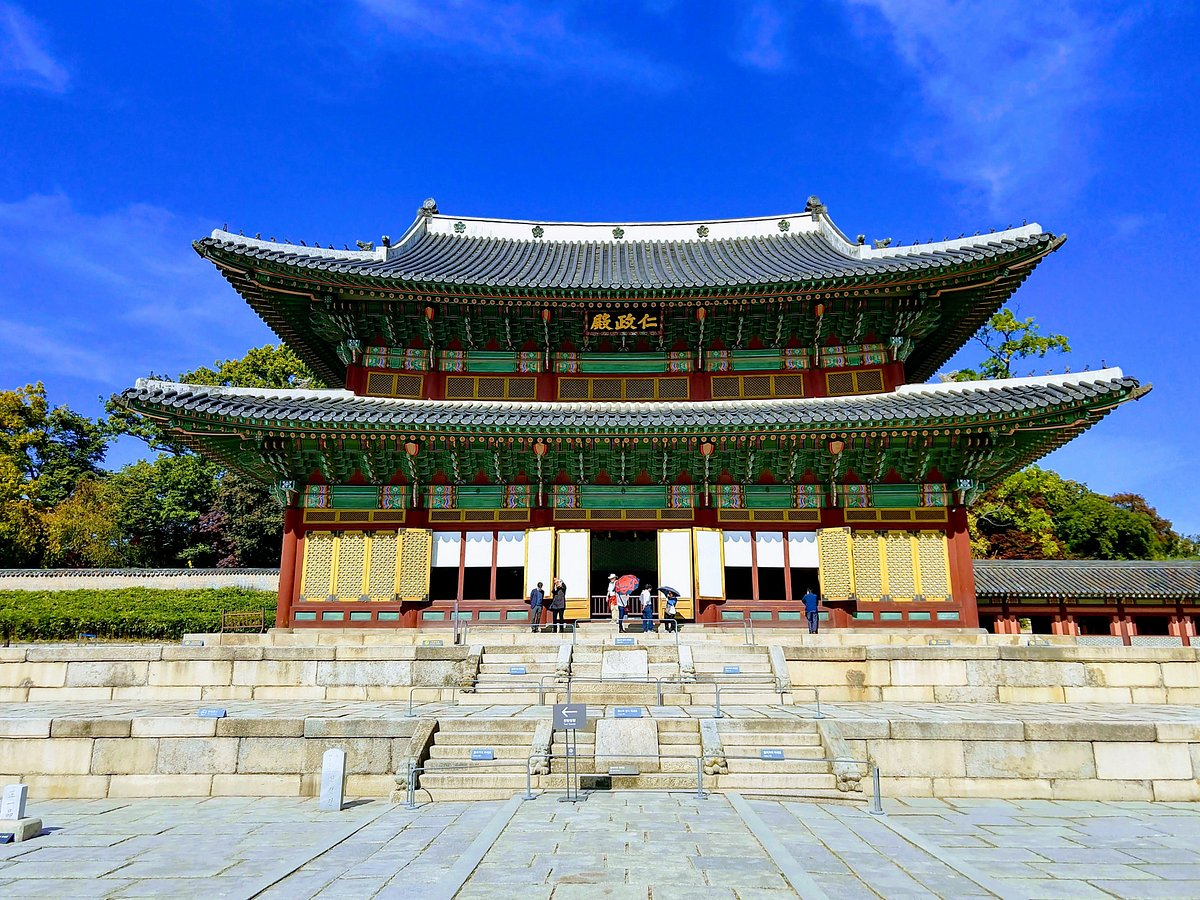Could you explain the significance of the colors used in the architecture of the Changdeokgung Palace? The colors used in the architecture of Changdeokgung Palace are deeply symbolic in Korean tradition. The green tiles of the roof represent earth, embodying peace and a grounding presence, while the red and gold accents symbolize wealth, prosperity, and the divine. These colors were chosen not only for aesthetic beauty but to convey the importance and sanctity of the palace as a political and cultural center during the Joseon Dynasty. 